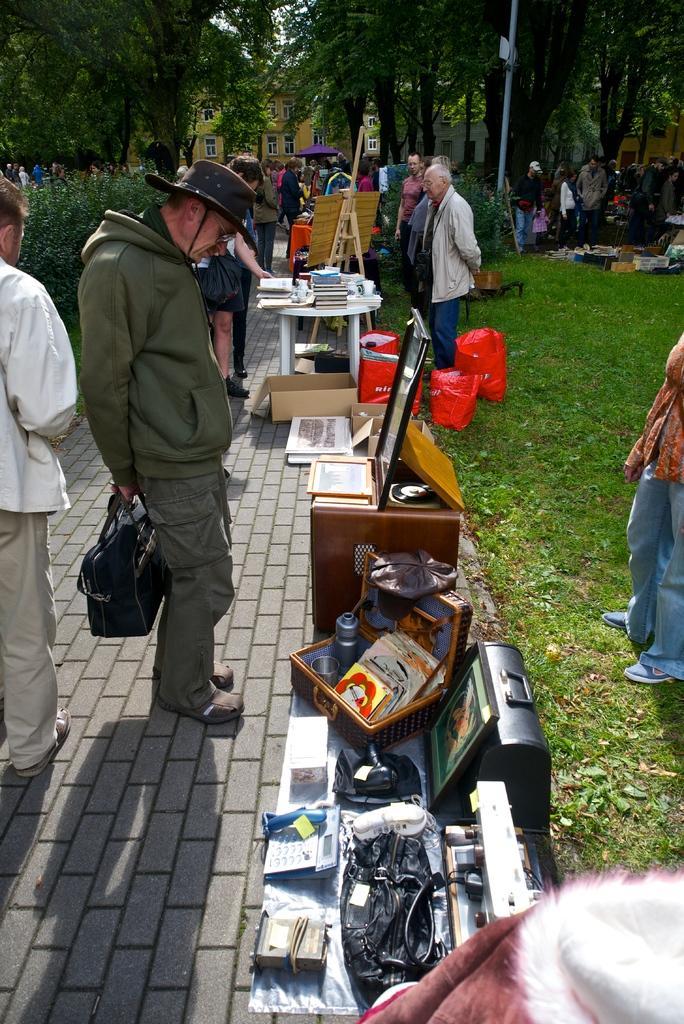Describe this image in one or two sentences. In this image, we can see a group of people and some objects, tables, boards, carton box, carry bags. Here we can see a footpath. Right side of the image, there is a grass. Background we can see so many trees, plants, houses with windows, pole. Left side of the image, we can see a man is holding a bag and wearing a hat. 